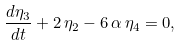Convert formula to latex. <formula><loc_0><loc_0><loc_500><loc_500>\frac { d \eta _ { 3 } } { d t } + 2 \, \eta _ { 2 } - 6 \, \alpha \, \eta _ { 4 } = 0 ,</formula> 